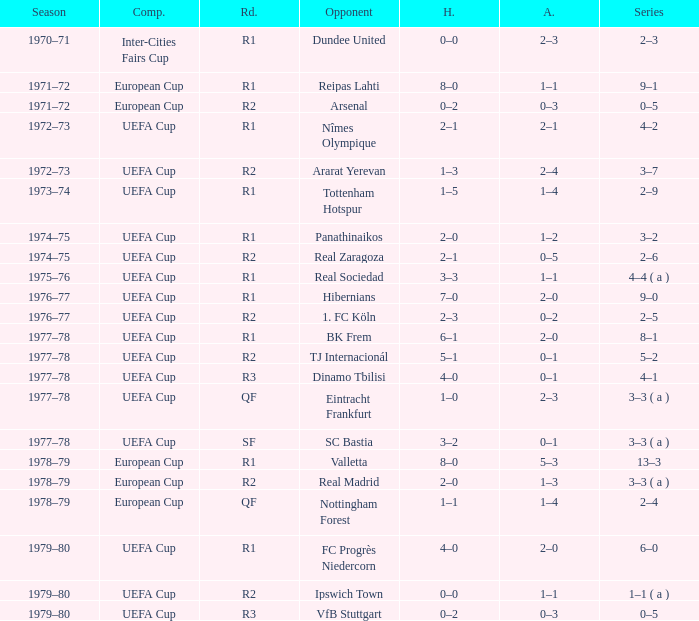Which Season has an Opponent of hibernians? 1976–77. 